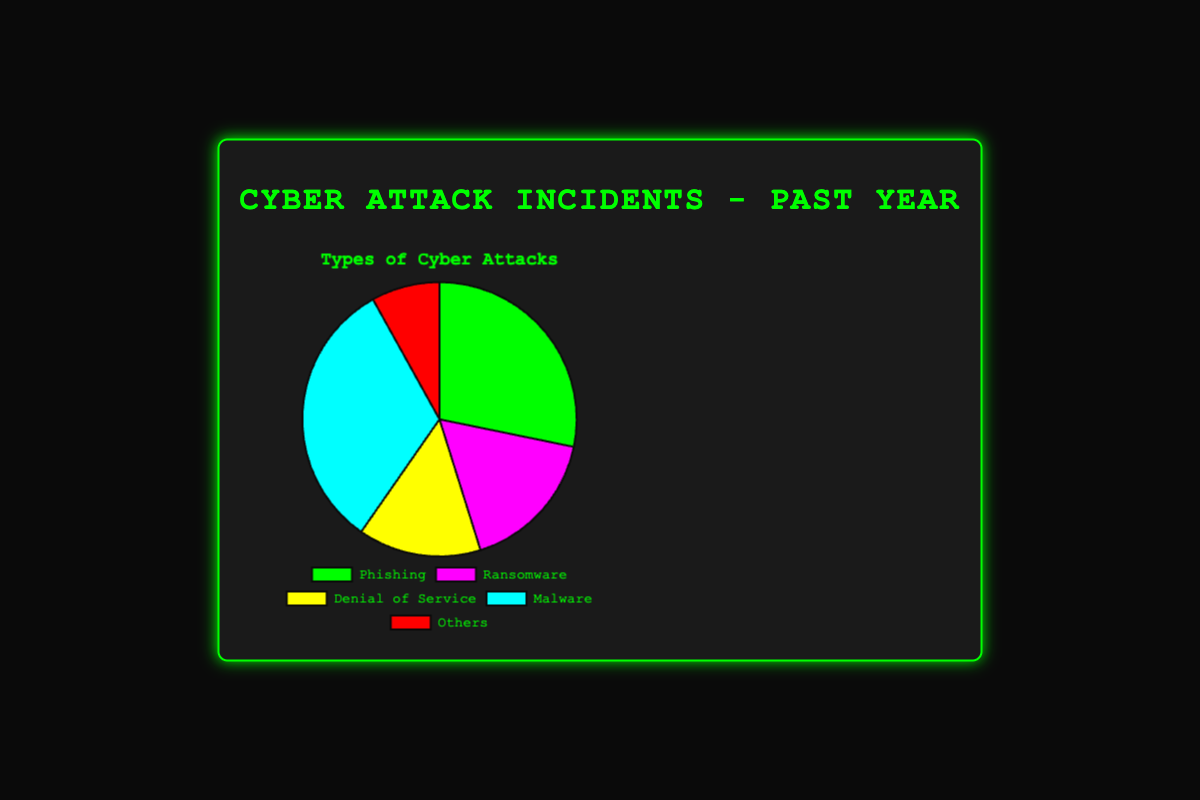What percentage of total incidents are Phishing attacks? To find the percentage of Phishing incidents, you need to divide the number of Phishing incidents (3500) by the total number of incidents and then multiply by 100. Total incidents = 3500 (Phishing) + 2100 (Ransomware) + 1800 (Denial of Service) + 4000 (Malware) + 1000 (Others) = 12400. Thus, the percentage is (3500 / 12400) * 100 ≈ 28.23%.
Answer: 28.23% Which type of cyber attack has the highest number of incidents? By visually comparing the segments of the pie chart, we can observe the largest segment represents Malware, with 4000 incidents.
Answer: Malware How does the number of Ransomware incidents compare with the number of Denial of Service incidents? Compare the two numbers directly from the chart: 2100 incidents for Ransomware and 1800 incidents for Denial of Service. Ransomware has 300 more incidents than Denial of Service.
Answer: Ransomware has more What is the sum of incidents from Phishing and Malware attacks? To find the sum, add the number of incidents of Phishing (3500) and Malware (4000). So, 3500 + 4000 = 7500.
Answer: 7500 What proportion of the total does the 'Others' category represent? Divide the number of 'Others' incidents (1000) by the total number of incidents (12400), the proportion is 1000/12400 ≈ 0.0806 or 8.06%.
Answer: 8.06% Is the visual color used for the Denial of Service segment green? By observing the segments of the pie chart, the Denial of Service segment is colored yellow.
Answer: No, it's yellow What is the difference between the number of Malware incidents and Phishing incidents? Subtract the number of Phishing incidents from the number of Malware incidents: 4000 - 3500 = 500.
Answer: 500 If the number of 'Other' incidents doubled, how many total incidents would there be? Double the 'Others' incidents, resulting in 1000 * 2 = 2000. Add this to the original total: 12400 - 1000 (original Others) + 2000 (doubled Others) = 13400.
Answer: 13400 Which attack type has more incidents: Phishing or Ransomware? Compare their incident numbers directly: Phishing (3500) and Ransomware (2100). Phishing has more incidents.
Answer: Phishing What is the average number of incidents per attack type? To find the average, divide the total number of incidents by the number of attack types: 12400 / 5 = 2480.
Answer: 2480 